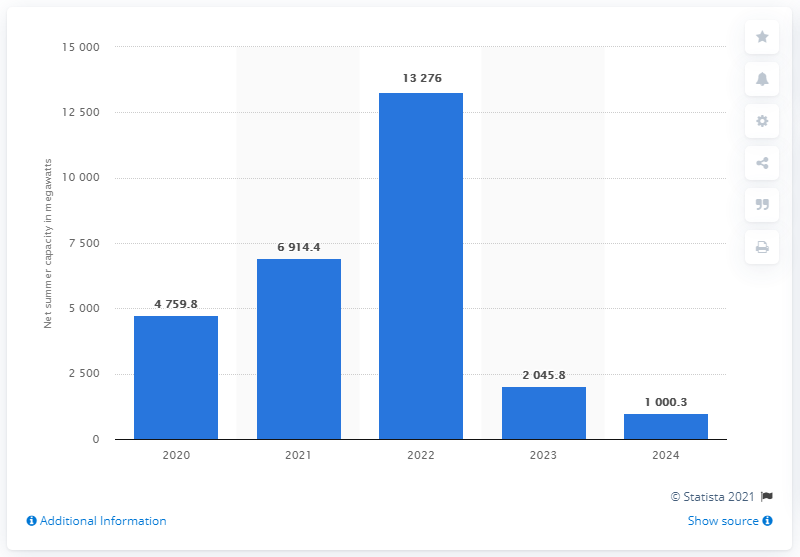Mention a couple of crucial points in this snapshot. The largest addition to the U.S. power grid is expected to occur in 2022. 